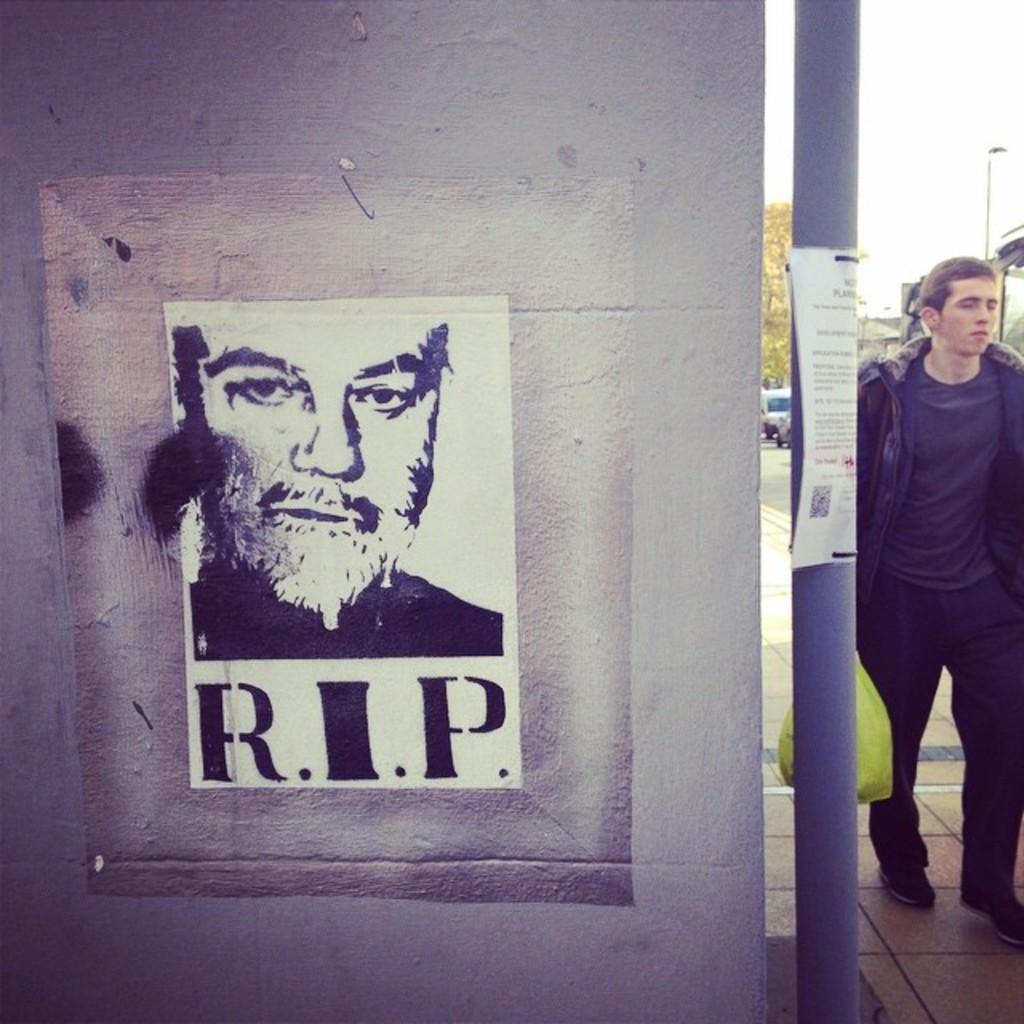Describe this image in one or two sentences. In the image there is a wall and on the wall there is a poster, on the right side there is a pole and behind the pole there is a man. 